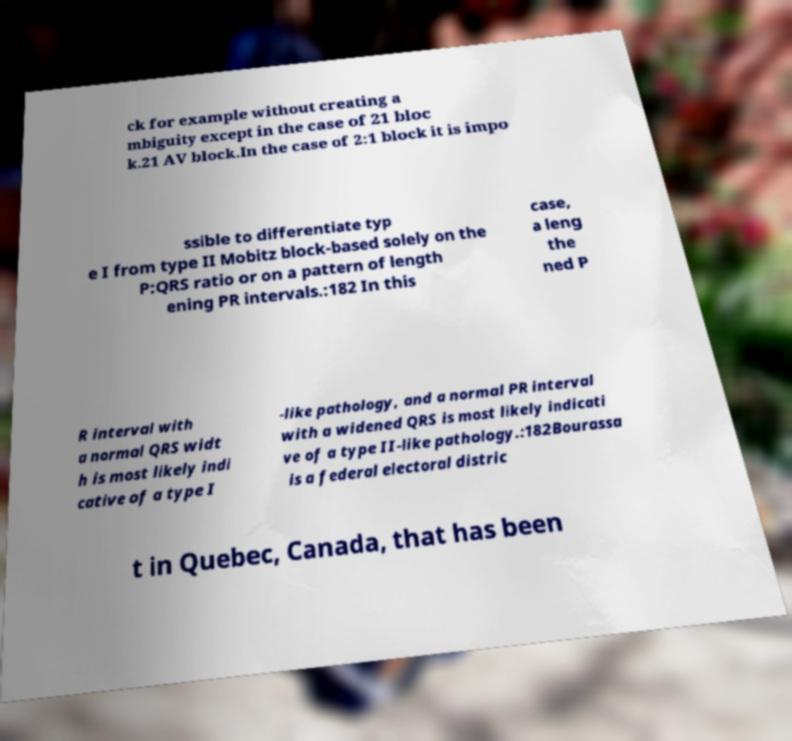What messages or text are displayed in this image? I need them in a readable, typed format. ck for example without creating a mbiguity except in the case of 21 bloc k.21 AV block.In the case of 2:1 block it is impo ssible to differentiate typ e I from type II Mobitz block-based solely on the P:QRS ratio or on a pattern of length ening PR intervals.:182 In this case, a leng the ned P R interval with a normal QRS widt h is most likely indi cative of a type I -like pathology, and a normal PR interval with a widened QRS is most likely indicati ve of a type II-like pathology.:182Bourassa is a federal electoral distric t in Quebec, Canada, that has been 